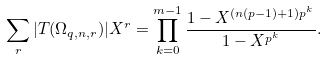<formula> <loc_0><loc_0><loc_500><loc_500>\sum _ { r } | T ( \Omega _ { q , n , r } ) | X ^ { r } = \prod _ { k = 0 } ^ { m - 1 } \frac { 1 - X ^ { ( n ( p - 1 ) + 1 ) p ^ { k } } } { 1 - X ^ { p ^ { k } } } .</formula> 